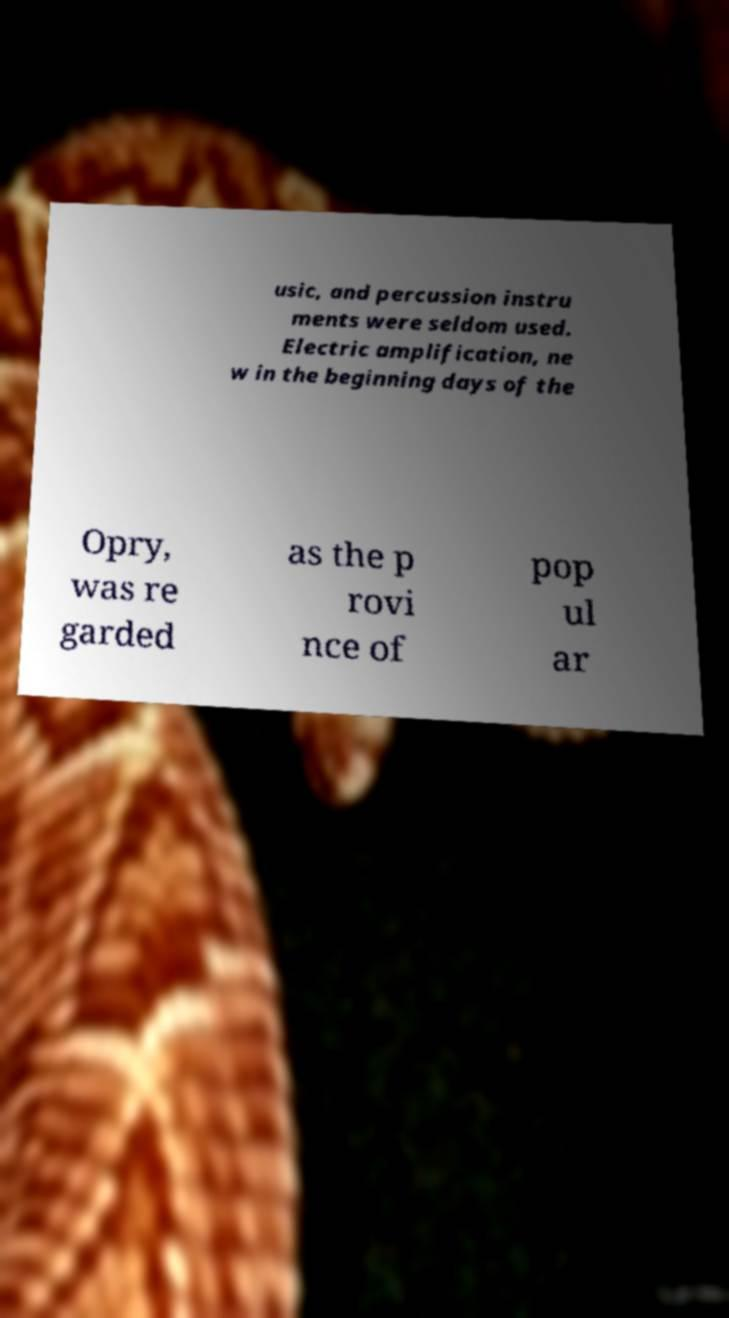What messages or text are displayed in this image? I need them in a readable, typed format. usic, and percussion instru ments were seldom used. Electric amplification, ne w in the beginning days of the Opry, was re garded as the p rovi nce of pop ul ar 